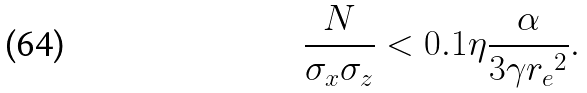Convert formula to latex. <formula><loc_0><loc_0><loc_500><loc_500>\frac { N } { \sigma _ { x } \sigma _ { z } } < 0 . 1 \eta \frac { \alpha } { 3 \gamma { r _ { e } } ^ { 2 } } .</formula> 